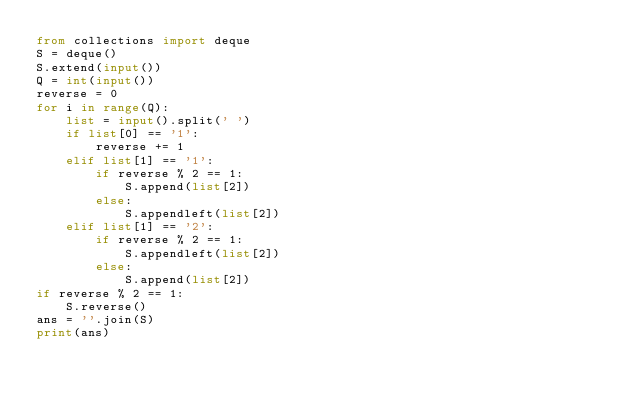<code> <loc_0><loc_0><loc_500><loc_500><_Python_>from collections import deque
S = deque()
S.extend(input())
Q = int(input())
reverse = 0
for i in range(Q):
    list = input().split(' ')
    if list[0] == '1':
        reverse += 1
    elif list[1] == '1':
        if reverse % 2 == 1:
            S.append(list[2])
        else:
            S.appendleft(list[2])
    elif list[1] == '2':
        if reverse % 2 == 1:
            S.appendleft(list[2])
        else:
            S.append(list[2])
if reverse % 2 == 1:
    S.reverse()
ans = ''.join(S)
print(ans)</code> 